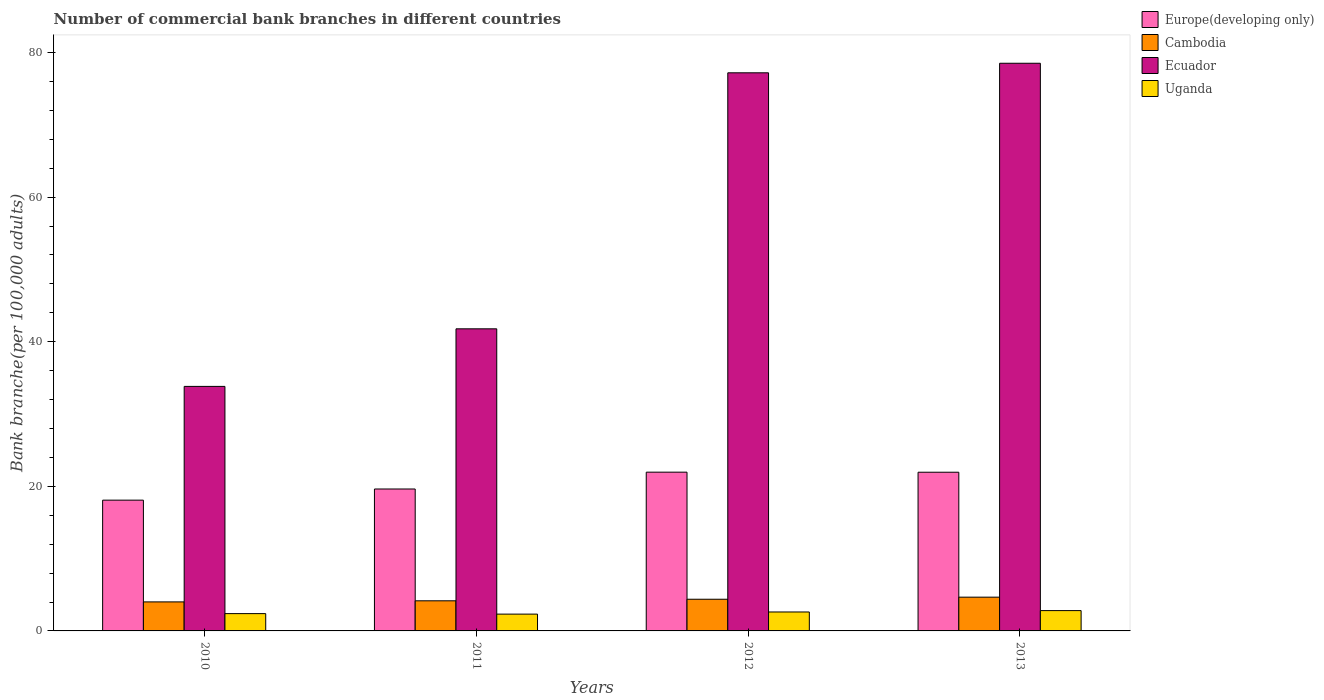What is the label of the 3rd group of bars from the left?
Provide a short and direct response. 2012. In how many cases, is the number of bars for a given year not equal to the number of legend labels?
Keep it short and to the point. 0. What is the number of commercial bank branches in Cambodia in 2010?
Your answer should be compact. 4.01. Across all years, what is the maximum number of commercial bank branches in Uganda?
Make the answer very short. 2.81. Across all years, what is the minimum number of commercial bank branches in Uganda?
Provide a succinct answer. 2.32. In which year was the number of commercial bank branches in Ecuador minimum?
Provide a succinct answer. 2010. What is the total number of commercial bank branches in Ecuador in the graph?
Your answer should be compact. 231.31. What is the difference between the number of commercial bank branches in Europe(developing only) in 2010 and that in 2013?
Your response must be concise. -3.86. What is the difference between the number of commercial bank branches in Uganda in 2011 and the number of commercial bank branches in Europe(developing only) in 2012?
Make the answer very short. -19.63. What is the average number of commercial bank branches in Cambodia per year?
Your answer should be very brief. 4.31. In the year 2013, what is the difference between the number of commercial bank branches in Europe(developing only) and number of commercial bank branches in Cambodia?
Your response must be concise. 17.28. In how many years, is the number of commercial bank branches in Europe(developing only) greater than 76?
Your answer should be very brief. 0. What is the ratio of the number of commercial bank branches in Uganda in 2010 to that in 2013?
Your response must be concise. 0.85. Is the number of commercial bank branches in Europe(developing only) in 2011 less than that in 2013?
Give a very brief answer. Yes. Is the difference between the number of commercial bank branches in Europe(developing only) in 2010 and 2013 greater than the difference between the number of commercial bank branches in Cambodia in 2010 and 2013?
Ensure brevity in your answer.  No. What is the difference between the highest and the second highest number of commercial bank branches in Cambodia?
Make the answer very short. 0.29. What is the difference between the highest and the lowest number of commercial bank branches in Ecuador?
Provide a succinct answer. 44.7. In how many years, is the number of commercial bank branches in Cambodia greater than the average number of commercial bank branches in Cambodia taken over all years?
Your answer should be compact. 2. Is the sum of the number of commercial bank branches in Europe(developing only) in 2010 and 2012 greater than the maximum number of commercial bank branches in Uganda across all years?
Provide a short and direct response. Yes. Is it the case that in every year, the sum of the number of commercial bank branches in Ecuador and number of commercial bank branches in Europe(developing only) is greater than the sum of number of commercial bank branches in Uganda and number of commercial bank branches in Cambodia?
Your answer should be very brief. Yes. What does the 4th bar from the left in 2012 represents?
Offer a terse response. Uganda. What does the 1st bar from the right in 2011 represents?
Provide a succinct answer. Uganda. Is it the case that in every year, the sum of the number of commercial bank branches in Ecuador and number of commercial bank branches in Uganda is greater than the number of commercial bank branches in Europe(developing only)?
Offer a terse response. Yes. How many bars are there?
Offer a terse response. 16. Are all the bars in the graph horizontal?
Your answer should be very brief. No. How many years are there in the graph?
Give a very brief answer. 4. What is the difference between two consecutive major ticks on the Y-axis?
Provide a short and direct response. 20. Does the graph contain any zero values?
Your answer should be compact. No. Where does the legend appear in the graph?
Your answer should be compact. Top right. How many legend labels are there?
Ensure brevity in your answer.  4. What is the title of the graph?
Offer a terse response. Number of commercial bank branches in different countries. What is the label or title of the X-axis?
Your answer should be compact. Years. What is the label or title of the Y-axis?
Give a very brief answer. Bank branche(per 100,0 adults). What is the Bank branche(per 100,000 adults) of Europe(developing only) in 2010?
Ensure brevity in your answer.  18.09. What is the Bank branche(per 100,000 adults) in Cambodia in 2010?
Provide a short and direct response. 4.01. What is the Bank branche(per 100,000 adults) of Ecuador in 2010?
Your answer should be compact. 33.82. What is the Bank branche(per 100,000 adults) in Uganda in 2010?
Provide a short and direct response. 2.39. What is the Bank branche(per 100,000 adults) in Europe(developing only) in 2011?
Provide a succinct answer. 19.63. What is the Bank branche(per 100,000 adults) of Cambodia in 2011?
Provide a short and direct response. 4.16. What is the Bank branche(per 100,000 adults) of Ecuador in 2011?
Ensure brevity in your answer.  41.78. What is the Bank branche(per 100,000 adults) in Uganda in 2011?
Give a very brief answer. 2.32. What is the Bank branche(per 100,000 adults) of Europe(developing only) in 2012?
Offer a terse response. 21.96. What is the Bank branche(per 100,000 adults) of Cambodia in 2012?
Your answer should be very brief. 4.38. What is the Bank branche(per 100,000 adults) of Ecuador in 2012?
Provide a succinct answer. 77.19. What is the Bank branche(per 100,000 adults) in Uganda in 2012?
Keep it short and to the point. 2.62. What is the Bank branche(per 100,000 adults) in Europe(developing only) in 2013?
Your answer should be compact. 21.95. What is the Bank branche(per 100,000 adults) of Cambodia in 2013?
Offer a terse response. 4.67. What is the Bank branche(per 100,000 adults) in Ecuador in 2013?
Provide a short and direct response. 78.52. What is the Bank branche(per 100,000 adults) of Uganda in 2013?
Your answer should be compact. 2.81. Across all years, what is the maximum Bank branche(per 100,000 adults) of Europe(developing only)?
Give a very brief answer. 21.96. Across all years, what is the maximum Bank branche(per 100,000 adults) in Cambodia?
Offer a terse response. 4.67. Across all years, what is the maximum Bank branche(per 100,000 adults) of Ecuador?
Ensure brevity in your answer.  78.52. Across all years, what is the maximum Bank branche(per 100,000 adults) of Uganda?
Make the answer very short. 2.81. Across all years, what is the minimum Bank branche(per 100,000 adults) of Europe(developing only)?
Ensure brevity in your answer.  18.09. Across all years, what is the minimum Bank branche(per 100,000 adults) of Cambodia?
Keep it short and to the point. 4.01. Across all years, what is the minimum Bank branche(per 100,000 adults) of Ecuador?
Provide a succinct answer. 33.82. Across all years, what is the minimum Bank branche(per 100,000 adults) of Uganda?
Your response must be concise. 2.32. What is the total Bank branche(per 100,000 adults) in Europe(developing only) in the graph?
Give a very brief answer. 81.63. What is the total Bank branche(per 100,000 adults) in Cambodia in the graph?
Ensure brevity in your answer.  17.23. What is the total Bank branche(per 100,000 adults) of Ecuador in the graph?
Your answer should be compact. 231.31. What is the total Bank branche(per 100,000 adults) of Uganda in the graph?
Your answer should be compact. 10.15. What is the difference between the Bank branche(per 100,000 adults) of Europe(developing only) in 2010 and that in 2011?
Provide a succinct answer. -1.54. What is the difference between the Bank branche(per 100,000 adults) of Cambodia in 2010 and that in 2011?
Offer a terse response. -0.15. What is the difference between the Bank branche(per 100,000 adults) in Ecuador in 2010 and that in 2011?
Provide a short and direct response. -7.96. What is the difference between the Bank branche(per 100,000 adults) in Uganda in 2010 and that in 2011?
Your answer should be compact. 0.07. What is the difference between the Bank branche(per 100,000 adults) of Europe(developing only) in 2010 and that in 2012?
Make the answer very short. -3.87. What is the difference between the Bank branche(per 100,000 adults) of Cambodia in 2010 and that in 2012?
Provide a succinct answer. -0.37. What is the difference between the Bank branche(per 100,000 adults) in Ecuador in 2010 and that in 2012?
Offer a terse response. -43.37. What is the difference between the Bank branche(per 100,000 adults) of Uganda in 2010 and that in 2012?
Keep it short and to the point. -0.23. What is the difference between the Bank branche(per 100,000 adults) of Europe(developing only) in 2010 and that in 2013?
Your answer should be very brief. -3.86. What is the difference between the Bank branche(per 100,000 adults) of Cambodia in 2010 and that in 2013?
Keep it short and to the point. -0.66. What is the difference between the Bank branche(per 100,000 adults) of Ecuador in 2010 and that in 2013?
Your answer should be very brief. -44.7. What is the difference between the Bank branche(per 100,000 adults) in Uganda in 2010 and that in 2013?
Provide a succinct answer. -0.42. What is the difference between the Bank branche(per 100,000 adults) in Europe(developing only) in 2011 and that in 2012?
Offer a very short reply. -2.33. What is the difference between the Bank branche(per 100,000 adults) in Cambodia in 2011 and that in 2012?
Give a very brief answer. -0.22. What is the difference between the Bank branche(per 100,000 adults) of Ecuador in 2011 and that in 2012?
Your response must be concise. -35.41. What is the difference between the Bank branche(per 100,000 adults) of Uganda in 2011 and that in 2012?
Your response must be concise. -0.3. What is the difference between the Bank branche(per 100,000 adults) in Europe(developing only) in 2011 and that in 2013?
Make the answer very short. -2.32. What is the difference between the Bank branche(per 100,000 adults) in Cambodia in 2011 and that in 2013?
Provide a short and direct response. -0.5. What is the difference between the Bank branche(per 100,000 adults) of Ecuador in 2011 and that in 2013?
Your answer should be compact. -36.73. What is the difference between the Bank branche(per 100,000 adults) of Uganda in 2011 and that in 2013?
Make the answer very short. -0.49. What is the difference between the Bank branche(per 100,000 adults) in Europe(developing only) in 2012 and that in 2013?
Offer a very short reply. 0.01. What is the difference between the Bank branche(per 100,000 adults) of Cambodia in 2012 and that in 2013?
Keep it short and to the point. -0.29. What is the difference between the Bank branche(per 100,000 adults) in Ecuador in 2012 and that in 2013?
Offer a terse response. -1.32. What is the difference between the Bank branche(per 100,000 adults) in Uganda in 2012 and that in 2013?
Give a very brief answer. -0.19. What is the difference between the Bank branche(per 100,000 adults) in Europe(developing only) in 2010 and the Bank branche(per 100,000 adults) in Cambodia in 2011?
Your answer should be very brief. 13.92. What is the difference between the Bank branche(per 100,000 adults) of Europe(developing only) in 2010 and the Bank branche(per 100,000 adults) of Ecuador in 2011?
Keep it short and to the point. -23.7. What is the difference between the Bank branche(per 100,000 adults) of Europe(developing only) in 2010 and the Bank branche(per 100,000 adults) of Uganda in 2011?
Offer a terse response. 15.76. What is the difference between the Bank branche(per 100,000 adults) of Cambodia in 2010 and the Bank branche(per 100,000 adults) of Ecuador in 2011?
Provide a short and direct response. -37.77. What is the difference between the Bank branche(per 100,000 adults) of Cambodia in 2010 and the Bank branche(per 100,000 adults) of Uganda in 2011?
Offer a very short reply. 1.69. What is the difference between the Bank branche(per 100,000 adults) of Ecuador in 2010 and the Bank branche(per 100,000 adults) of Uganda in 2011?
Offer a very short reply. 31.5. What is the difference between the Bank branche(per 100,000 adults) of Europe(developing only) in 2010 and the Bank branche(per 100,000 adults) of Cambodia in 2012?
Your answer should be compact. 13.71. What is the difference between the Bank branche(per 100,000 adults) of Europe(developing only) in 2010 and the Bank branche(per 100,000 adults) of Ecuador in 2012?
Your response must be concise. -59.11. What is the difference between the Bank branche(per 100,000 adults) of Europe(developing only) in 2010 and the Bank branche(per 100,000 adults) of Uganda in 2012?
Provide a short and direct response. 15.47. What is the difference between the Bank branche(per 100,000 adults) in Cambodia in 2010 and the Bank branche(per 100,000 adults) in Ecuador in 2012?
Make the answer very short. -73.18. What is the difference between the Bank branche(per 100,000 adults) in Cambodia in 2010 and the Bank branche(per 100,000 adults) in Uganda in 2012?
Provide a short and direct response. 1.39. What is the difference between the Bank branche(per 100,000 adults) of Ecuador in 2010 and the Bank branche(per 100,000 adults) of Uganda in 2012?
Give a very brief answer. 31.2. What is the difference between the Bank branche(per 100,000 adults) in Europe(developing only) in 2010 and the Bank branche(per 100,000 adults) in Cambodia in 2013?
Keep it short and to the point. 13.42. What is the difference between the Bank branche(per 100,000 adults) of Europe(developing only) in 2010 and the Bank branche(per 100,000 adults) of Ecuador in 2013?
Your response must be concise. -60.43. What is the difference between the Bank branche(per 100,000 adults) in Europe(developing only) in 2010 and the Bank branche(per 100,000 adults) in Uganda in 2013?
Offer a very short reply. 15.28. What is the difference between the Bank branche(per 100,000 adults) of Cambodia in 2010 and the Bank branche(per 100,000 adults) of Ecuador in 2013?
Your answer should be very brief. -74.5. What is the difference between the Bank branche(per 100,000 adults) in Cambodia in 2010 and the Bank branche(per 100,000 adults) in Uganda in 2013?
Give a very brief answer. 1.2. What is the difference between the Bank branche(per 100,000 adults) of Ecuador in 2010 and the Bank branche(per 100,000 adults) of Uganda in 2013?
Give a very brief answer. 31.01. What is the difference between the Bank branche(per 100,000 adults) of Europe(developing only) in 2011 and the Bank branche(per 100,000 adults) of Cambodia in 2012?
Ensure brevity in your answer.  15.25. What is the difference between the Bank branche(per 100,000 adults) in Europe(developing only) in 2011 and the Bank branche(per 100,000 adults) in Ecuador in 2012?
Your answer should be compact. -57.56. What is the difference between the Bank branche(per 100,000 adults) in Europe(developing only) in 2011 and the Bank branche(per 100,000 adults) in Uganda in 2012?
Ensure brevity in your answer.  17.01. What is the difference between the Bank branche(per 100,000 adults) in Cambodia in 2011 and the Bank branche(per 100,000 adults) in Ecuador in 2012?
Offer a very short reply. -73.03. What is the difference between the Bank branche(per 100,000 adults) in Cambodia in 2011 and the Bank branche(per 100,000 adults) in Uganda in 2012?
Your response must be concise. 1.54. What is the difference between the Bank branche(per 100,000 adults) of Ecuador in 2011 and the Bank branche(per 100,000 adults) of Uganda in 2012?
Keep it short and to the point. 39.16. What is the difference between the Bank branche(per 100,000 adults) in Europe(developing only) in 2011 and the Bank branche(per 100,000 adults) in Cambodia in 2013?
Offer a very short reply. 14.96. What is the difference between the Bank branche(per 100,000 adults) in Europe(developing only) in 2011 and the Bank branche(per 100,000 adults) in Ecuador in 2013?
Provide a succinct answer. -58.88. What is the difference between the Bank branche(per 100,000 adults) of Europe(developing only) in 2011 and the Bank branche(per 100,000 adults) of Uganda in 2013?
Your answer should be compact. 16.82. What is the difference between the Bank branche(per 100,000 adults) in Cambodia in 2011 and the Bank branche(per 100,000 adults) in Ecuador in 2013?
Ensure brevity in your answer.  -74.35. What is the difference between the Bank branche(per 100,000 adults) of Cambodia in 2011 and the Bank branche(per 100,000 adults) of Uganda in 2013?
Make the answer very short. 1.35. What is the difference between the Bank branche(per 100,000 adults) in Ecuador in 2011 and the Bank branche(per 100,000 adults) in Uganda in 2013?
Your answer should be very brief. 38.97. What is the difference between the Bank branche(per 100,000 adults) in Europe(developing only) in 2012 and the Bank branche(per 100,000 adults) in Cambodia in 2013?
Offer a terse response. 17.29. What is the difference between the Bank branche(per 100,000 adults) of Europe(developing only) in 2012 and the Bank branche(per 100,000 adults) of Ecuador in 2013?
Ensure brevity in your answer.  -56.56. What is the difference between the Bank branche(per 100,000 adults) of Europe(developing only) in 2012 and the Bank branche(per 100,000 adults) of Uganda in 2013?
Your response must be concise. 19.15. What is the difference between the Bank branche(per 100,000 adults) of Cambodia in 2012 and the Bank branche(per 100,000 adults) of Ecuador in 2013?
Your response must be concise. -74.13. What is the difference between the Bank branche(per 100,000 adults) of Cambodia in 2012 and the Bank branche(per 100,000 adults) of Uganda in 2013?
Provide a succinct answer. 1.57. What is the difference between the Bank branche(per 100,000 adults) of Ecuador in 2012 and the Bank branche(per 100,000 adults) of Uganda in 2013?
Provide a succinct answer. 74.38. What is the average Bank branche(per 100,000 adults) of Europe(developing only) per year?
Provide a succinct answer. 20.41. What is the average Bank branche(per 100,000 adults) in Cambodia per year?
Offer a terse response. 4.31. What is the average Bank branche(per 100,000 adults) in Ecuador per year?
Give a very brief answer. 57.83. What is the average Bank branche(per 100,000 adults) of Uganda per year?
Your answer should be very brief. 2.54. In the year 2010, what is the difference between the Bank branche(per 100,000 adults) of Europe(developing only) and Bank branche(per 100,000 adults) of Cambodia?
Provide a short and direct response. 14.07. In the year 2010, what is the difference between the Bank branche(per 100,000 adults) of Europe(developing only) and Bank branche(per 100,000 adults) of Ecuador?
Your answer should be very brief. -15.73. In the year 2010, what is the difference between the Bank branche(per 100,000 adults) in Europe(developing only) and Bank branche(per 100,000 adults) in Uganda?
Your response must be concise. 15.7. In the year 2010, what is the difference between the Bank branche(per 100,000 adults) of Cambodia and Bank branche(per 100,000 adults) of Ecuador?
Offer a very short reply. -29.81. In the year 2010, what is the difference between the Bank branche(per 100,000 adults) of Cambodia and Bank branche(per 100,000 adults) of Uganda?
Ensure brevity in your answer.  1.62. In the year 2010, what is the difference between the Bank branche(per 100,000 adults) of Ecuador and Bank branche(per 100,000 adults) of Uganda?
Your response must be concise. 31.43. In the year 2011, what is the difference between the Bank branche(per 100,000 adults) of Europe(developing only) and Bank branche(per 100,000 adults) of Cambodia?
Your answer should be compact. 15.47. In the year 2011, what is the difference between the Bank branche(per 100,000 adults) of Europe(developing only) and Bank branche(per 100,000 adults) of Ecuador?
Keep it short and to the point. -22.15. In the year 2011, what is the difference between the Bank branche(per 100,000 adults) in Europe(developing only) and Bank branche(per 100,000 adults) in Uganda?
Provide a succinct answer. 17.31. In the year 2011, what is the difference between the Bank branche(per 100,000 adults) in Cambodia and Bank branche(per 100,000 adults) in Ecuador?
Keep it short and to the point. -37.62. In the year 2011, what is the difference between the Bank branche(per 100,000 adults) of Cambodia and Bank branche(per 100,000 adults) of Uganda?
Offer a terse response. 1.84. In the year 2011, what is the difference between the Bank branche(per 100,000 adults) in Ecuador and Bank branche(per 100,000 adults) in Uganda?
Your answer should be compact. 39.46. In the year 2012, what is the difference between the Bank branche(per 100,000 adults) of Europe(developing only) and Bank branche(per 100,000 adults) of Cambodia?
Ensure brevity in your answer.  17.58. In the year 2012, what is the difference between the Bank branche(per 100,000 adults) in Europe(developing only) and Bank branche(per 100,000 adults) in Ecuador?
Your answer should be very brief. -55.24. In the year 2012, what is the difference between the Bank branche(per 100,000 adults) of Europe(developing only) and Bank branche(per 100,000 adults) of Uganda?
Provide a short and direct response. 19.34. In the year 2012, what is the difference between the Bank branche(per 100,000 adults) of Cambodia and Bank branche(per 100,000 adults) of Ecuador?
Your answer should be very brief. -72.81. In the year 2012, what is the difference between the Bank branche(per 100,000 adults) of Cambodia and Bank branche(per 100,000 adults) of Uganda?
Make the answer very short. 1.76. In the year 2012, what is the difference between the Bank branche(per 100,000 adults) in Ecuador and Bank branche(per 100,000 adults) in Uganda?
Offer a terse response. 74.57. In the year 2013, what is the difference between the Bank branche(per 100,000 adults) in Europe(developing only) and Bank branche(per 100,000 adults) in Cambodia?
Ensure brevity in your answer.  17.28. In the year 2013, what is the difference between the Bank branche(per 100,000 adults) in Europe(developing only) and Bank branche(per 100,000 adults) in Ecuador?
Provide a short and direct response. -56.57. In the year 2013, what is the difference between the Bank branche(per 100,000 adults) in Europe(developing only) and Bank branche(per 100,000 adults) in Uganda?
Make the answer very short. 19.14. In the year 2013, what is the difference between the Bank branche(per 100,000 adults) of Cambodia and Bank branche(per 100,000 adults) of Ecuador?
Provide a succinct answer. -73.85. In the year 2013, what is the difference between the Bank branche(per 100,000 adults) of Cambodia and Bank branche(per 100,000 adults) of Uganda?
Your response must be concise. 1.86. In the year 2013, what is the difference between the Bank branche(per 100,000 adults) in Ecuador and Bank branche(per 100,000 adults) in Uganda?
Your answer should be compact. 75.71. What is the ratio of the Bank branche(per 100,000 adults) of Europe(developing only) in 2010 to that in 2011?
Ensure brevity in your answer.  0.92. What is the ratio of the Bank branche(per 100,000 adults) in Cambodia in 2010 to that in 2011?
Provide a short and direct response. 0.96. What is the ratio of the Bank branche(per 100,000 adults) of Ecuador in 2010 to that in 2011?
Keep it short and to the point. 0.81. What is the ratio of the Bank branche(per 100,000 adults) of Uganda in 2010 to that in 2011?
Your answer should be compact. 1.03. What is the ratio of the Bank branche(per 100,000 adults) of Europe(developing only) in 2010 to that in 2012?
Offer a terse response. 0.82. What is the ratio of the Bank branche(per 100,000 adults) of Cambodia in 2010 to that in 2012?
Provide a succinct answer. 0.92. What is the ratio of the Bank branche(per 100,000 adults) in Ecuador in 2010 to that in 2012?
Your answer should be compact. 0.44. What is the ratio of the Bank branche(per 100,000 adults) in Uganda in 2010 to that in 2012?
Give a very brief answer. 0.91. What is the ratio of the Bank branche(per 100,000 adults) of Europe(developing only) in 2010 to that in 2013?
Provide a succinct answer. 0.82. What is the ratio of the Bank branche(per 100,000 adults) in Cambodia in 2010 to that in 2013?
Keep it short and to the point. 0.86. What is the ratio of the Bank branche(per 100,000 adults) in Ecuador in 2010 to that in 2013?
Your response must be concise. 0.43. What is the ratio of the Bank branche(per 100,000 adults) in Uganda in 2010 to that in 2013?
Provide a succinct answer. 0.85. What is the ratio of the Bank branche(per 100,000 adults) of Europe(developing only) in 2011 to that in 2012?
Your answer should be very brief. 0.89. What is the ratio of the Bank branche(per 100,000 adults) in Cambodia in 2011 to that in 2012?
Provide a succinct answer. 0.95. What is the ratio of the Bank branche(per 100,000 adults) in Ecuador in 2011 to that in 2012?
Provide a succinct answer. 0.54. What is the ratio of the Bank branche(per 100,000 adults) in Uganda in 2011 to that in 2012?
Give a very brief answer. 0.89. What is the ratio of the Bank branche(per 100,000 adults) of Europe(developing only) in 2011 to that in 2013?
Offer a terse response. 0.89. What is the ratio of the Bank branche(per 100,000 adults) in Cambodia in 2011 to that in 2013?
Your answer should be very brief. 0.89. What is the ratio of the Bank branche(per 100,000 adults) of Ecuador in 2011 to that in 2013?
Make the answer very short. 0.53. What is the ratio of the Bank branche(per 100,000 adults) in Uganda in 2011 to that in 2013?
Your response must be concise. 0.83. What is the ratio of the Bank branche(per 100,000 adults) of Europe(developing only) in 2012 to that in 2013?
Offer a very short reply. 1. What is the ratio of the Bank branche(per 100,000 adults) of Cambodia in 2012 to that in 2013?
Offer a very short reply. 0.94. What is the ratio of the Bank branche(per 100,000 adults) in Ecuador in 2012 to that in 2013?
Your answer should be very brief. 0.98. What is the ratio of the Bank branche(per 100,000 adults) of Uganda in 2012 to that in 2013?
Ensure brevity in your answer.  0.93. What is the difference between the highest and the second highest Bank branche(per 100,000 adults) of Europe(developing only)?
Offer a terse response. 0.01. What is the difference between the highest and the second highest Bank branche(per 100,000 adults) in Cambodia?
Ensure brevity in your answer.  0.29. What is the difference between the highest and the second highest Bank branche(per 100,000 adults) of Ecuador?
Provide a short and direct response. 1.32. What is the difference between the highest and the second highest Bank branche(per 100,000 adults) of Uganda?
Give a very brief answer. 0.19. What is the difference between the highest and the lowest Bank branche(per 100,000 adults) in Europe(developing only)?
Provide a short and direct response. 3.87. What is the difference between the highest and the lowest Bank branche(per 100,000 adults) of Cambodia?
Make the answer very short. 0.66. What is the difference between the highest and the lowest Bank branche(per 100,000 adults) in Ecuador?
Give a very brief answer. 44.7. What is the difference between the highest and the lowest Bank branche(per 100,000 adults) in Uganda?
Make the answer very short. 0.49. 